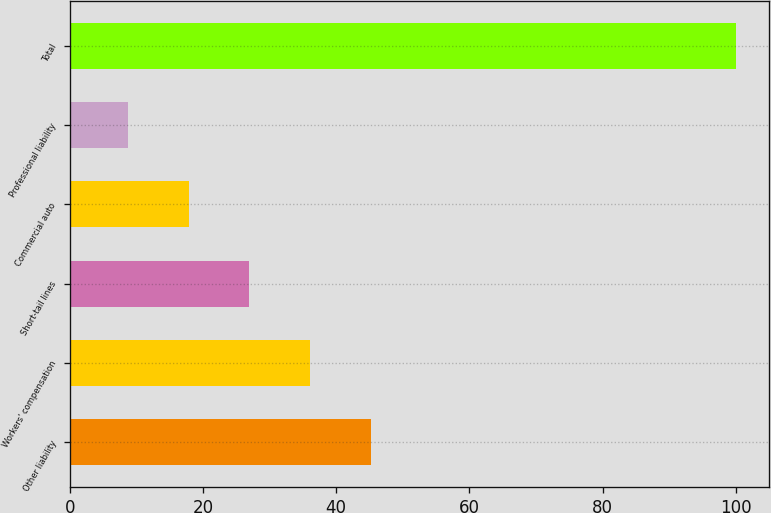Convert chart to OTSL. <chart><loc_0><loc_0><loc_500><loc_500><bar_chart><fcel>Other liability<fcel>Workers' compensation<fcel>Short-tail lines<fcel>Commercial auto<fcel>Professional liability<fcel>Total<nl><fcel>45.22<fcel>36.09<fcel>26.96<fcel>17.83<fcel>8.7<fcel>100<nl></chart> 